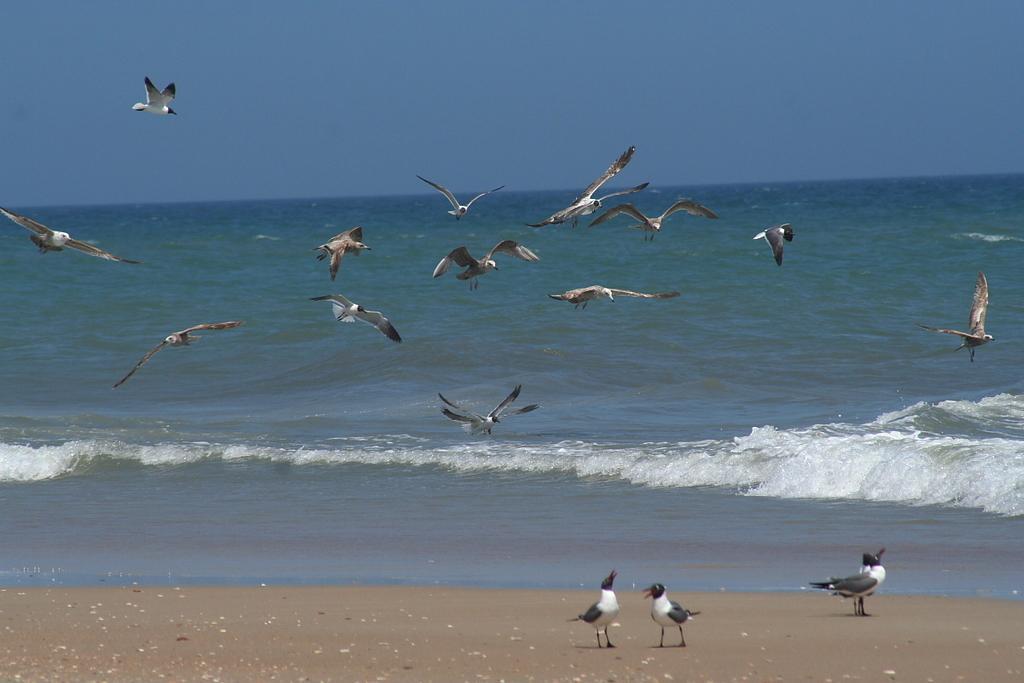In one or two sentences, can you explain what this image depicts? In this image there are birds flying and standing. In the background there is an ocean. 